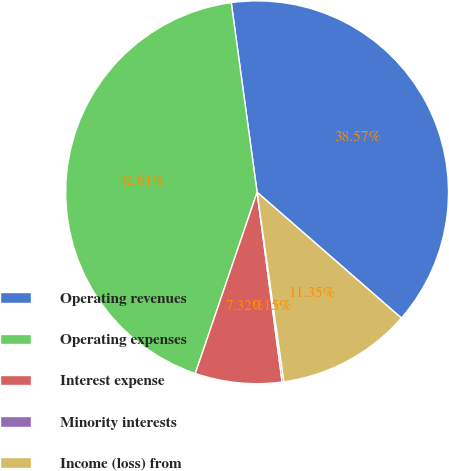<chart> <loc_0><loc_0><loc_500><loc_500><pie_chart><fcel>Operating revenues<fcel>Operating expenses<fcel>Interest expense<fcel>Minority interests<fcel>Income (loss) from<nl><fcel>38.57%<fcel>42.61%<fcel>7.32%<fcel>0.15%<fcel>11.35%<nl></chart> 